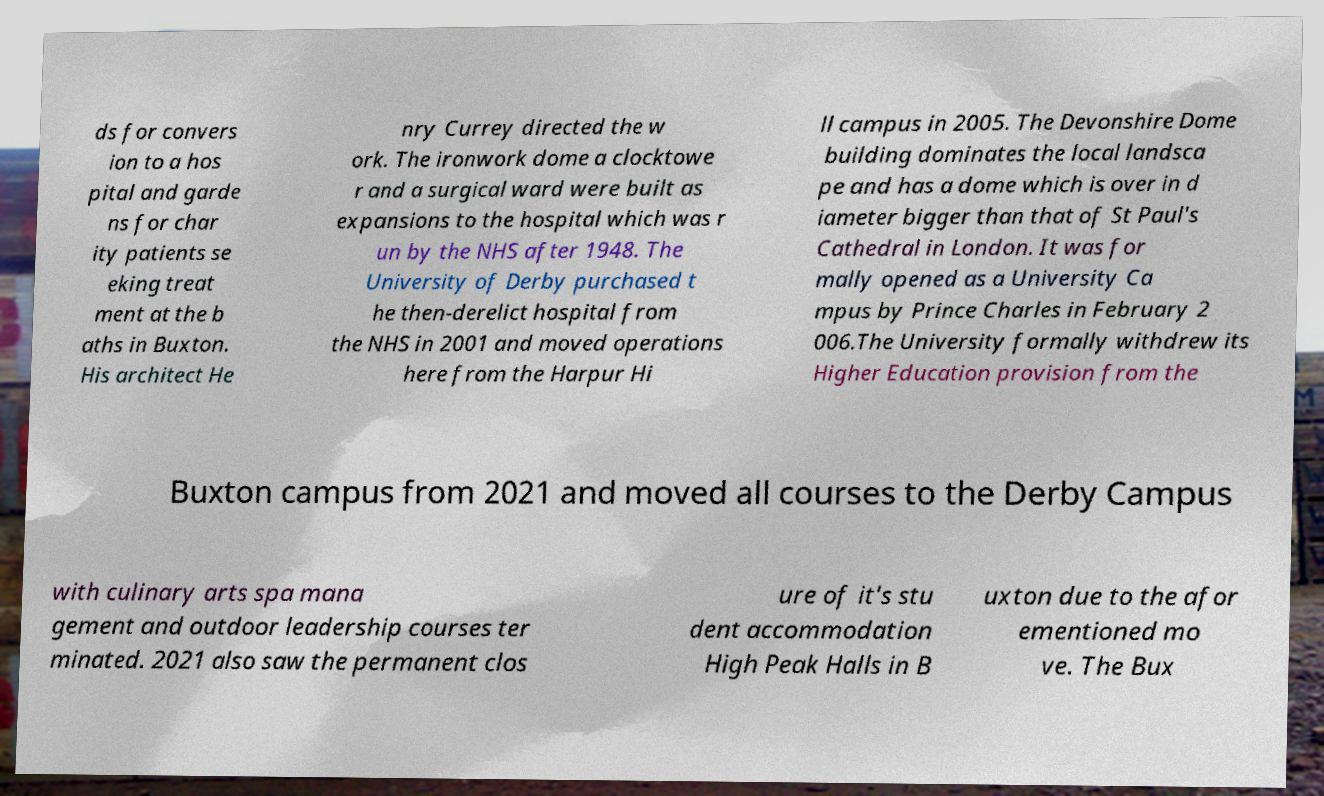What messages or text are displayed in this image? I need them in a readable, typed format. ds for convers ion to a hos pital and garde ns for char ity patients se eking treat ment at the b aths in Buxton. His architect He nry Currey directed the w ork. The ironwork dome a clocktowe r and a surgical ward were built as expansions to the hospital which was r un by the NHS after 1948. The University of Derby purchased t he then-derelict hospital from the NHS in 2001 and moved operations here from the Harpur Hi ll campus in 2005. The Devonshire Dome building dominates the local landsca pe and has a dome which is over in d iameter bigger than that of St Paul's Cathedral in London. It was for mally opened as a University Ca mpus by Prince Charles in February 2 006.The University formally withdrew its Higher Education provision from the Buxton campus from 2021 and moved all courses to the Derby Campus with culinary arts spa mana gement and outdoor leadership courses ter minated. 2021 also saw the permanent clos ure of it's stu dent accommodation High Peak Halls in B uxton due to the afor ementioned mo ve. The Bux 